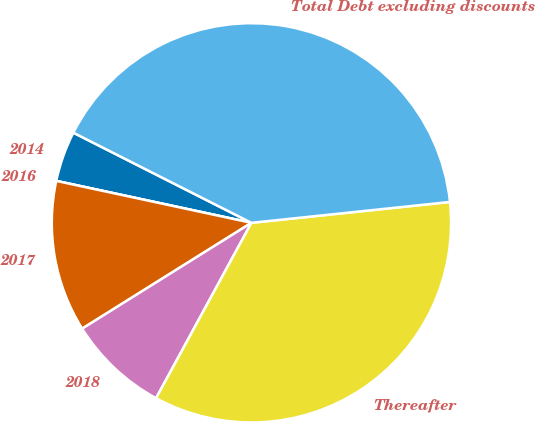Convert chart. <chart><loc_0><loc_0><loc_500><loc_500><pie_chart><fcel>2014<fcel>2016<fcel>2017<fcel>2018<fcel>Thereafter<fcel>Total Debt excluding discounts<nl><fcel>4.09%<fcel>0.0%<fcel>12.26%<fcel>8.18%<fcel>34.59%<fcel>40.87%<nl></chart> 